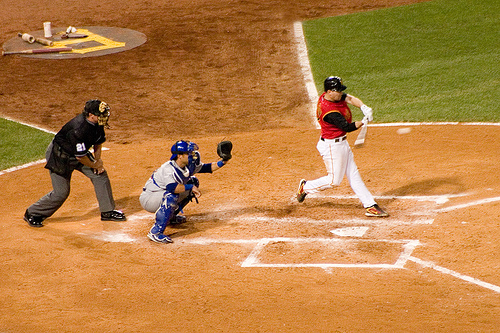Read all the text in this image. 21 